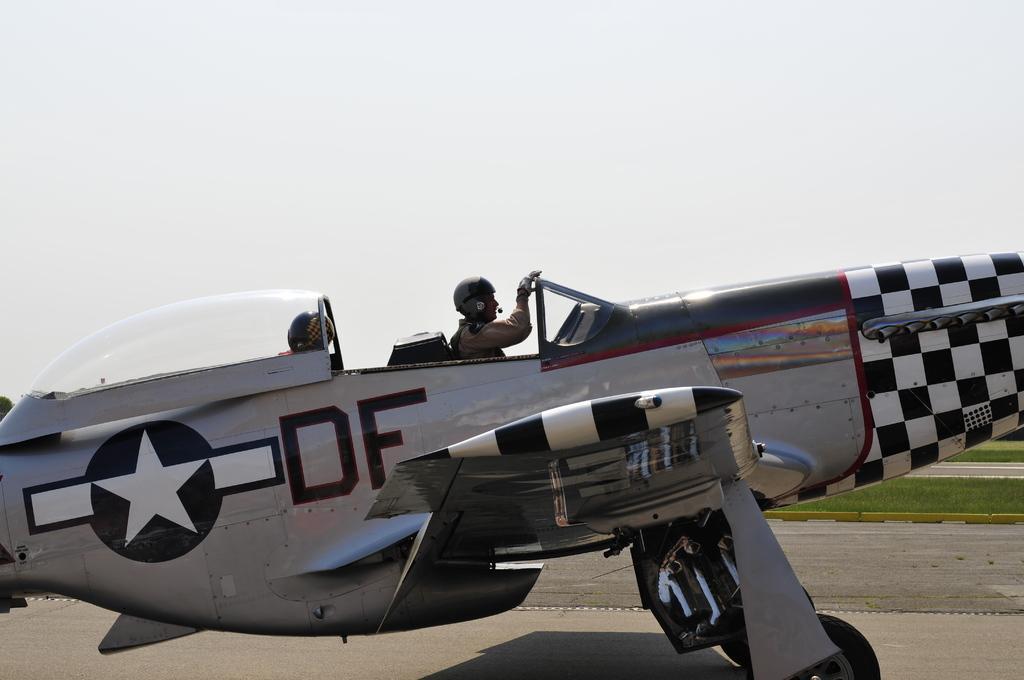Could you give a brief overview of what you see in this image? Here we can see two persons are sitting on a plane which is on the road. In the background there is grass on the ground and sky. On the left there is a tree. 